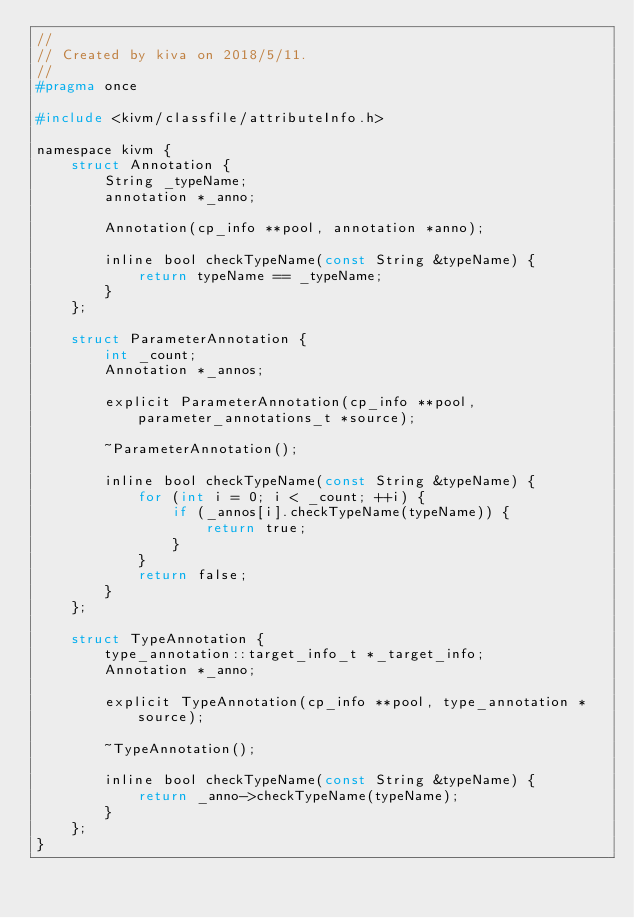Convert code to text. <code><loc_0><loc_0><loc_500><loc_500><_C_>//
// Created by kiva on 2018/5/11.
//
#pragma once

#include <kivm/classfile/attributeInfo.h>

namespace kivm {
    struct Annotation {
        String _typeName;
        annotation *_anno;

        Annotation(cp_info **pool, annotation *anno);

        inline bool checkTypeName(const String &typeName) {
            return typeName == _typeName;
        }
    };

    struct ParameterAnnotation {
        int _count;
        Annotation *_annos;

        explicit ParameterAnnotation(cp_info **pool, parameter_annotations_t *source);

        ~ParameterAnnotation();

        inline bool checkTypeName(const String &typeName) {
            for (int i = 0; i < _count; ++i) {
                if (_annos[i].checkTypeName(typeName)) {
                    return true;
                }
            }
            return false;
        }
    };

    struct TypeAnnotation {
        type_annotation::target_info_t *_target_info;
        Annotation *_anno;

        explicit TypeAnnotation(cp_info **pool, type_annotation *source);

        ~TypeAnnotation();

        inline bool checkTypeName(const String &typeName) {
            return _anno->checkTypeName(typeName);
        }
    };
}
</code> 